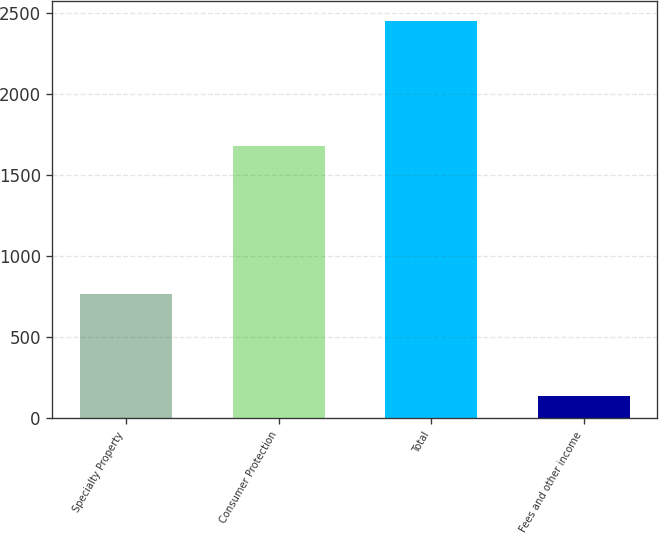Convert chart to OTSL. <chart><loc_0><loc_0><loc_500><loc_500><bar_chart><fcel>Specialty Property<fcel>Consumer Protection<fcel>Total<fcel>Fees and other income<nl><fcel>769<fcel>1680<fcel>2449<fcel>136<nl></chart> 